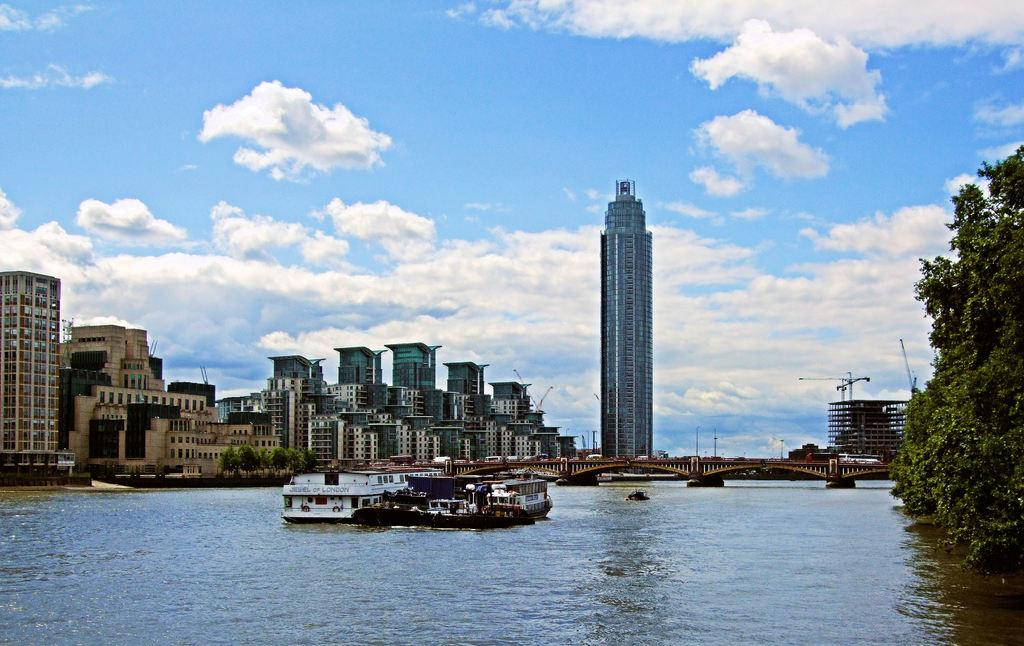What is on the water in the image? There are boats on the water in the image. What structure can be seen in the image? There is a bridge in the image. What type of structures are present in the image? There are buildings in the image. What type of vegetation is visible in the image? Trees are visible in the image. What else can be seen in the image? There are poles and other objects in the image. What is visible in the background of the image? The sky with clouds is visible in the background of the image. Where is the bucket of tomatoes in the image? There is no bucket of tomatoes present in the image. What type of kitty can be seen playing with the boats in the image? There is no kitty present in the image; it only features boats, a bridge, buildings, trees, poles, and other objects. 